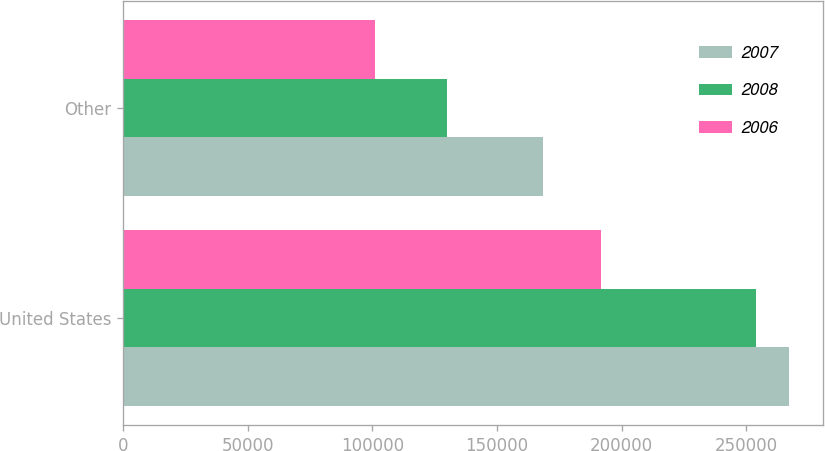Convert chart. <chart><loc_0><loc_0><loc_500><loc_500><stacked_bar_chart><ecel><fcel>United States<fcel>Other<nl><fcel>2007<fcel>267386<fcel>168569<nl><fcel>2008<fcel>253841<fcel>129816<nl><fcel>2006<fcel>191649<fcel>101223<nl></chart> 